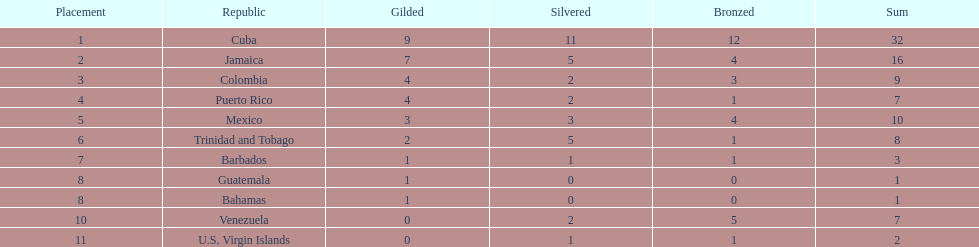The nation before mexico in the table Puerto Rico. 